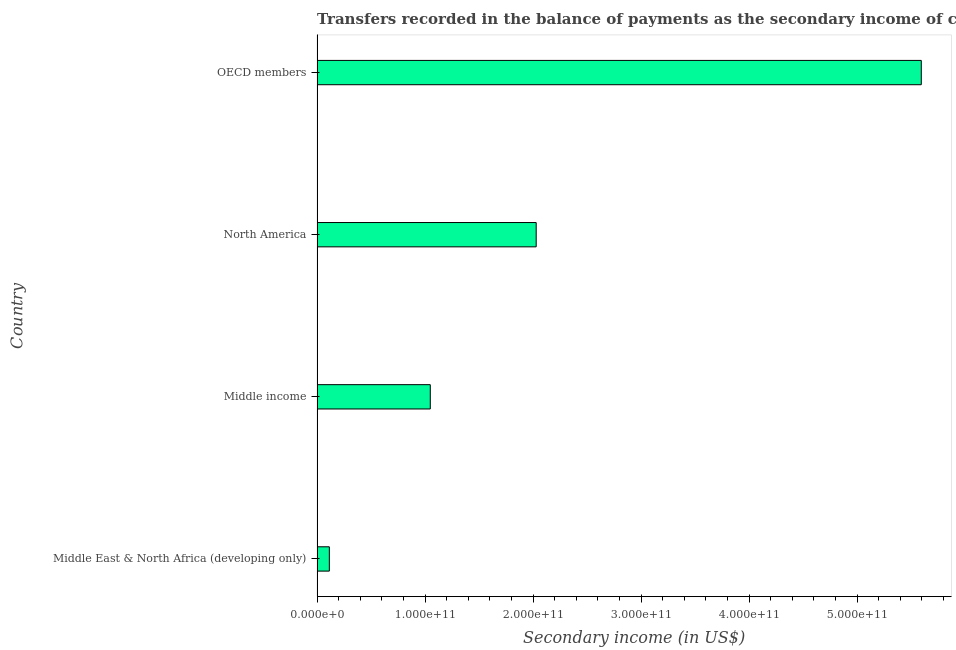Does the graph contain grids?
Provide a short and direct response. No. What is the title of the graph?
Offer a very short reply. Transfers recorded in the balance of payments as the secondary income of countries in the year 2013. What is the label or title of the X-axis?
Your answer should be compact. Secondary income (in US$). What is the label or title of the Y-axis?
Offer a very short reply. Country. What is the amount of secondary income in Middle income?
Offer a very short reply. 1.05e+11. Across all countries, what is the maximum amount of secondary income?
Keep it short and to the point. 5.59e+11. Across all countries, what is the minimum amount of secondary income?
Your answer should be compact. 1.14e+1. In which country was the amount of secondary income maximum?
Keep it short and to the point. OECD members. In which country was the amount of secondary income minimum?
Your answer should be compact. Middle East & North Africa (developing only). What is the sum of the amount of secondary income?
Make the answer very short. 8.79e+11. What is the difference between the amount of secondary income in Middle income and North America?
Keep it short and to the point. -9.81e+1. What is the average amount of secondary income per country?
Ensure brevity in your answer.  2.20e+11. What is the median amount of secondary income?
Provide a short and direct response. 1.54e+11. What is the ratio of the amount of secondary income in Middle income to that in OECD members?
Offer a very short reply. 0.19. Is the amount of secondary income in Middle East & North Africa (developing only) less than that in Middle income?
Ensure brevity in your answer.  Yes. What is the difference between the highest and the second highest amount of secondary income?
Offer a very short reply. 3.57e+11. Is the sum of the amount of secondary income in North America and OECD members greater than the maximum amount of secondary income across all countries?
Offer a very short reply. Yes. What is the difference between the highest and the lowest amount of secondary income?
Keep it short and to the point. 5.48e+11. Are all the bars in the graph horizontal?
Your response must be concise. Yes. How many countries are there in the graph?
Give a very brief answer. 4. What is the difference between two consecutive major ticks on the X-axis?
Offer a very short reply. 1.00e+11. What is the Secondary income (in US$) of Middle East & North Africa (developing only)?
Make the answer very short. 1.14e+1. What is the Secondary income (in US$) in Middle income?
Your answer should be very brief. 1.05e+11. What is the Secondary income (in US$) in North America?
Provide a short and direct response. 2.03e+11. What is the Secondary income (in US$) in OECD members?
Provide a succinct answer. 5.59e+11. What is the difference between the Secondary income (in US$) in Middle East & North Africa (developing only) and Middle income?
Give a very brief answer. -9.35e+1. What is the difference between the Secondary income (in US$) in Middle East & North Africa (developing only) and North America?
Keep it short and to the point. -1.92e+11. What is the difference between the Secondary income (in US$) in Middle East & North Africa (developing only) and OECD members?
Offer a very short reply. -5.48e+11. What is the difference between the Secondary income (in US$) in Middle income and North America?
Make the answer very short. -9.81e+1. What is the difference between the Secondary income (in US$) in Middle income and OECD members?
Your answer should be compact. -4.55e+11. What is the difference between the Secondary income (in US$) in North America and OECD members?
Your response must be concise. -3.57e+11. What is the ratio of the Secondary income (in US$) in Middle East & North Africa (developing only) to that in Middle income?
Ensure brevity in your answer.  0.11. What is the ratio of the Secondary income (in US$) in Middle East & North Africa (developing only) to that in North America?
Offer a very short reply. 0.06. What is the ratio of the Secondary income (in US$) in Middle income to that in North America?
Offer a terse response. 0.52. What is the ratio of the Secondary income (in US$) in Middle income to that in OECD members?
Ensure brevity in your answer.  0.19. What is the ratio of the Secondary income (in US$) in North America to that in OECD members?
Your answer should be very brief. 0.36. 